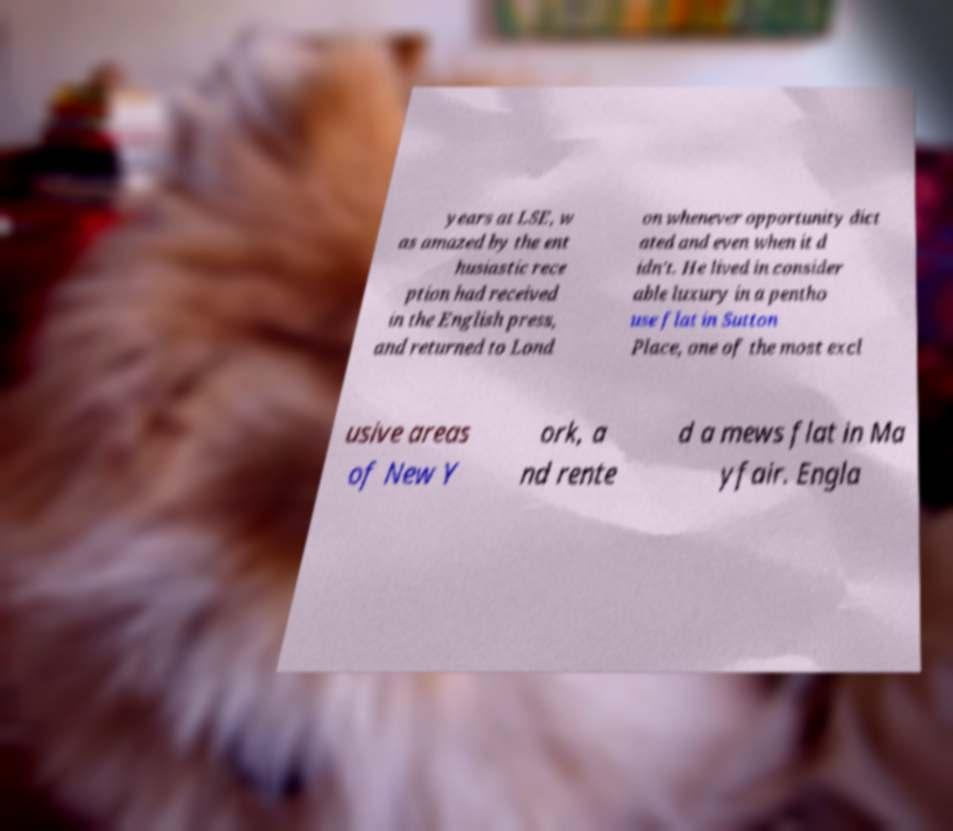There's text embedded in this image that I need extracted. Can you transcribe it verbatim? years at LSE, w as amazed by the ent husiastic rece ption had received in the English press, and returned to Lond on whenever opportunity dict ated and even when it d idn't. He lived in consider able luxury in a pentho use flat in Sutton Place, one of the most excl usive areas of New Y ork, a nd rente d a mews flat in Ma yfair. Engla 